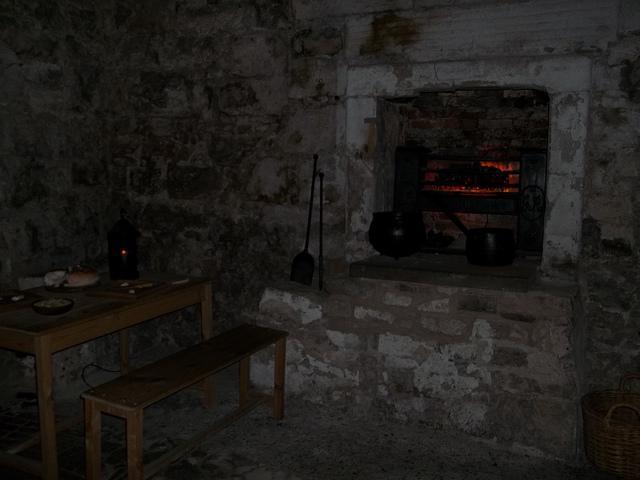What type of heat is shown?
Indicate the correct response by choosing from the four available options to answer the question.
Options: Radiator, blanket, fire, coat. Fire. 